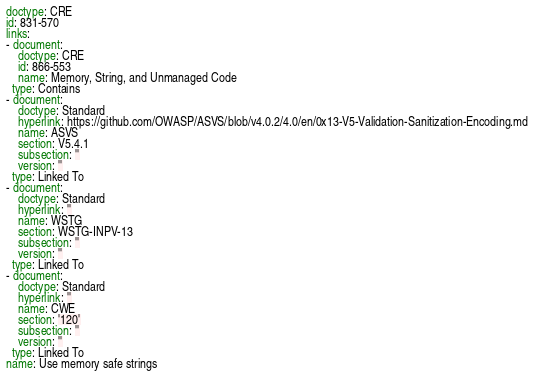<code> <loc_0><loc_0><loc_500><loc_500><_YAML_>doctype: CRE
id: 831-570
links:
- document:
    doctype: CRE
    id: 866-553
    name: Memory, String, and Unmanaged Code
  type: Contains
- document:
    doctype: Standard
    hyperlink: https://github.com/OWASP/ASVS/blob/v4.0.2/4.0/en/0x13-V5-Validation-Sanitization-Encoding.md
    name: ASVS
    section: V5.4.1
    subsection: ''
    version: ''
  type: Linked To
- document:
    doctype: Standard
    hyperlink: ''
    name: WSTG
    section: WSTG-INPV-13
    subsection: ''
    version: ''
  type: Linked To
- document:
    doctype: Standard
    hyperlink: ''
    name: CWE
    section: '120'
    subsection: ''
    version: ''
  type: Linked To
name: Use memory safe strings
</code> 